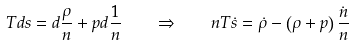Convert formula to latex. <formula><loc_0><loc_0><loc_500><loc_500>T d s = d \frac { \rho } { n } + p d \frac { 1 } { n } \quad \Rightarrow \quad n T \dot { s } = \dot { \rho } - \left ( \rho + p \right ) \frac { \dot { n } } { n }</formula> 